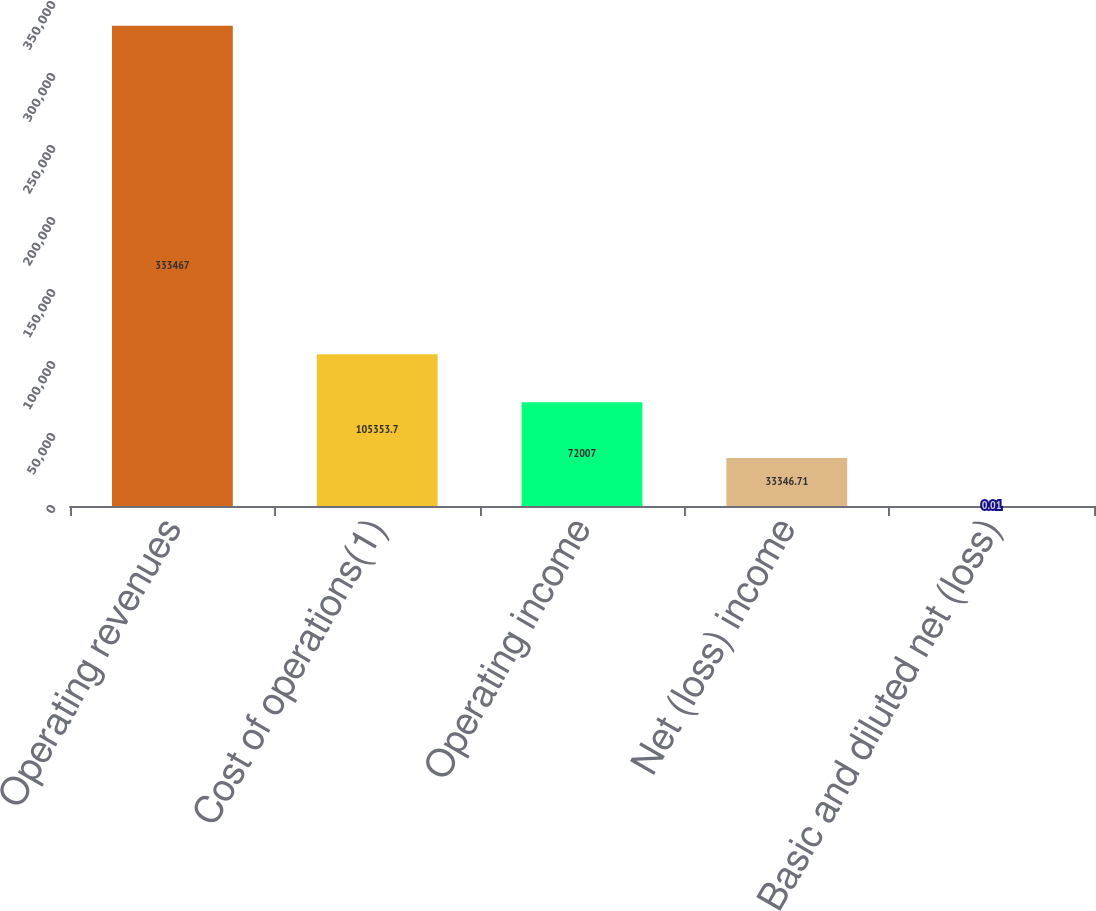Convert chart to OTSL. <chart><loc_0><loc_0><loc_500><loc_500><bar_chart><fcel>Operating revenues<fcel>Cost of operations(1)<fcel>Operating income<fcel>Net (loss) income<fcel>Basic and diluted net (loss)<nl><fcel>333467<fcel>105354<fcel>72007<fcel>33346.7<fcel>0.01<nl></chart> 